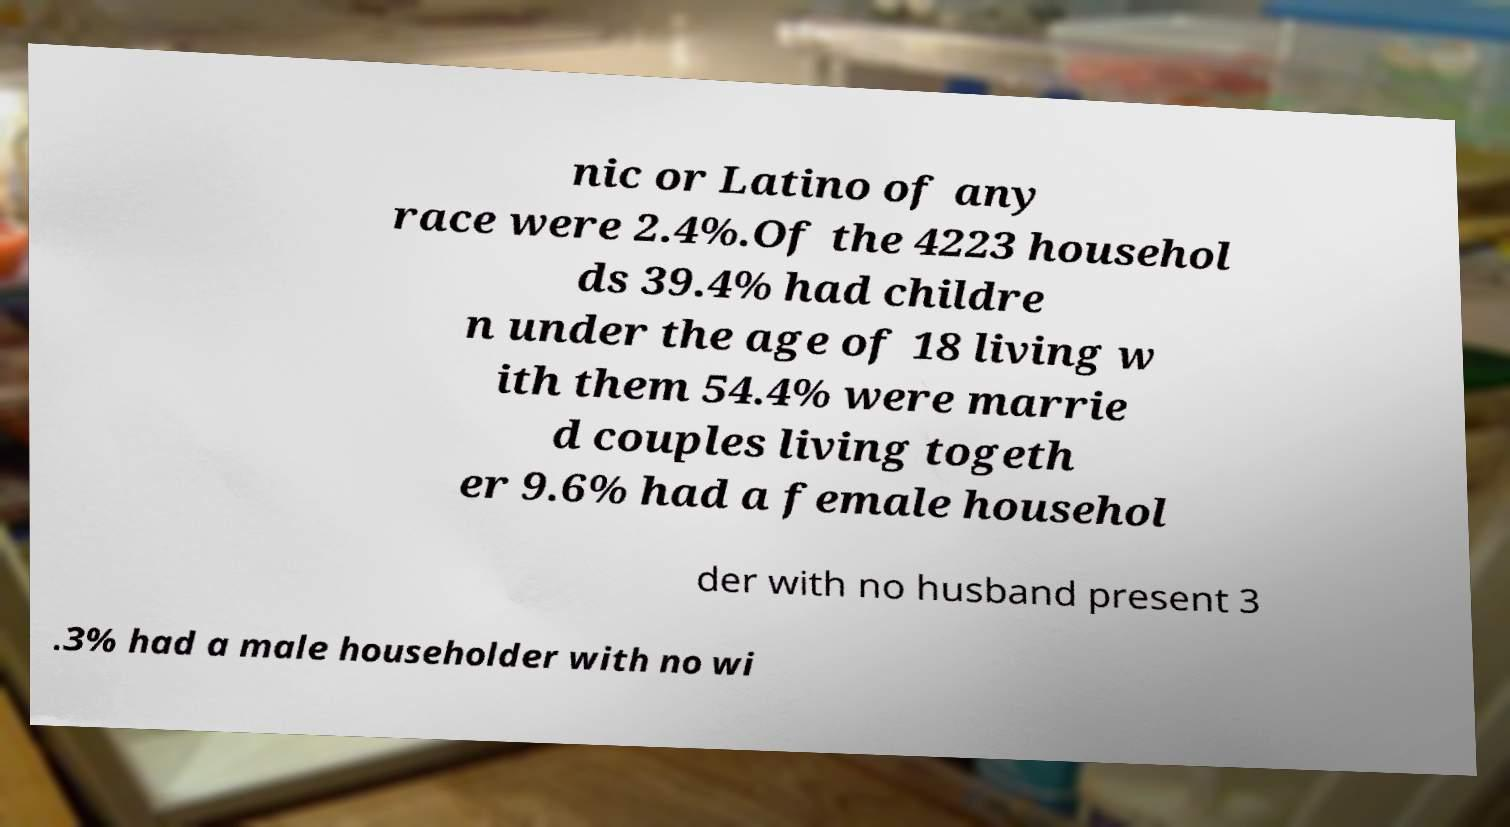Could you extract and type out the text from this image? nic or Latino of any race were 2.4%.Of the 4223 househol ds 39.4% had childre n under the age of 18 living w ith them 54.4% were marrie d couples living togeth er 9.6% had a female househol der with no husband present 3 .3% had a male householder with no wi 